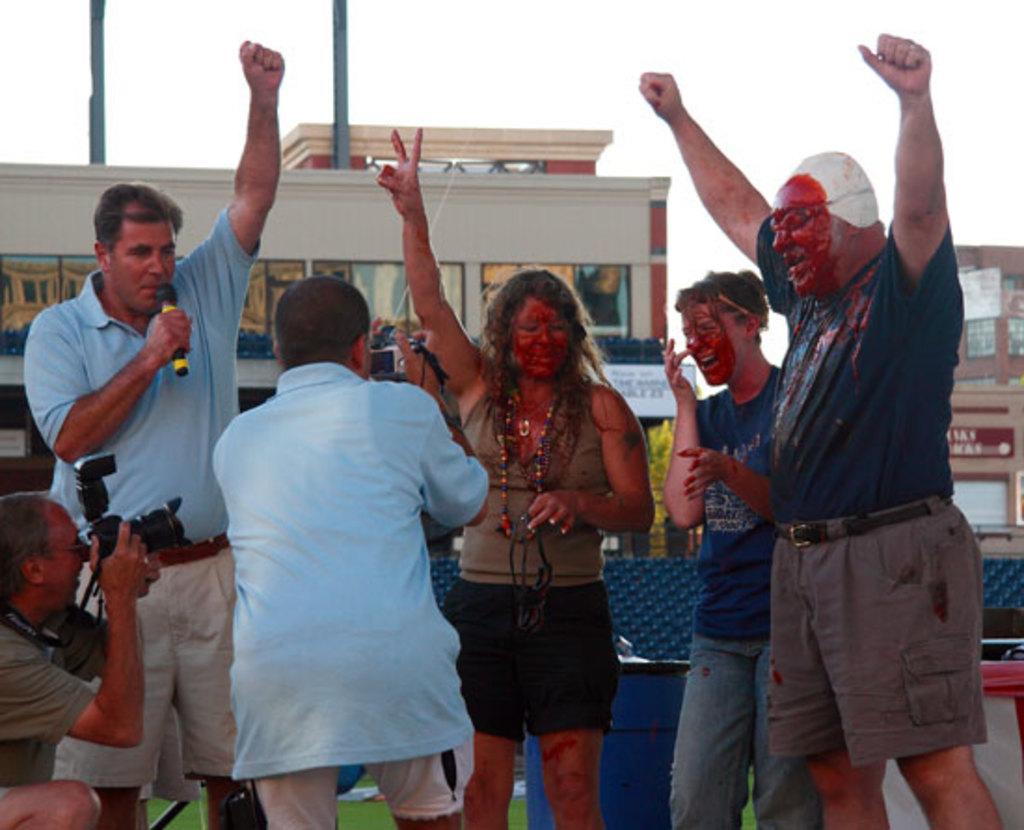Please provide a concise description of this image. In the center of the image we can see a few people are standing. Among them two persons are holding cameras and one person holding a microphone. And we can see few people are smiling. In the background, we can see the sky, clouds, buildings, banners, one barrel, one table and a few other objects. 